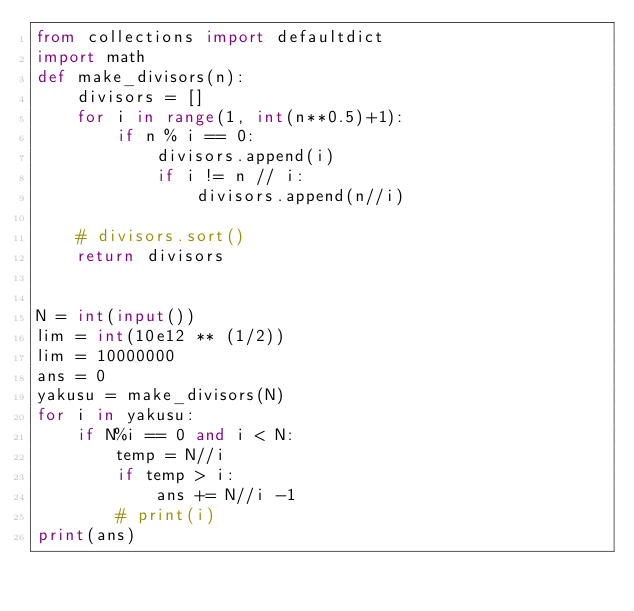<code> <loc_0><loc_0><loc_500><loc_500><_Python_>from collections import defaultdict
import math
def make_divisors(n):
    divisors = []
    for i in range(1, int(n**0.5)+1):
        if n % i == 0:
            divisors.append(i)
            if i != n // i:
                divisors.append(n//i)

    # divisors.sort()
    return divisors


N = int(input())
lim = int(10e12 ** (1/2))
lim = 10000000
ans = 0
yakusu = make_divisors(N)
for i in yakusu:
    if N%i == 0 and i < N:
        temp = N//i
        if temp > i:
            ans += N//i -1
        # print(i)
print(ans)</code> 